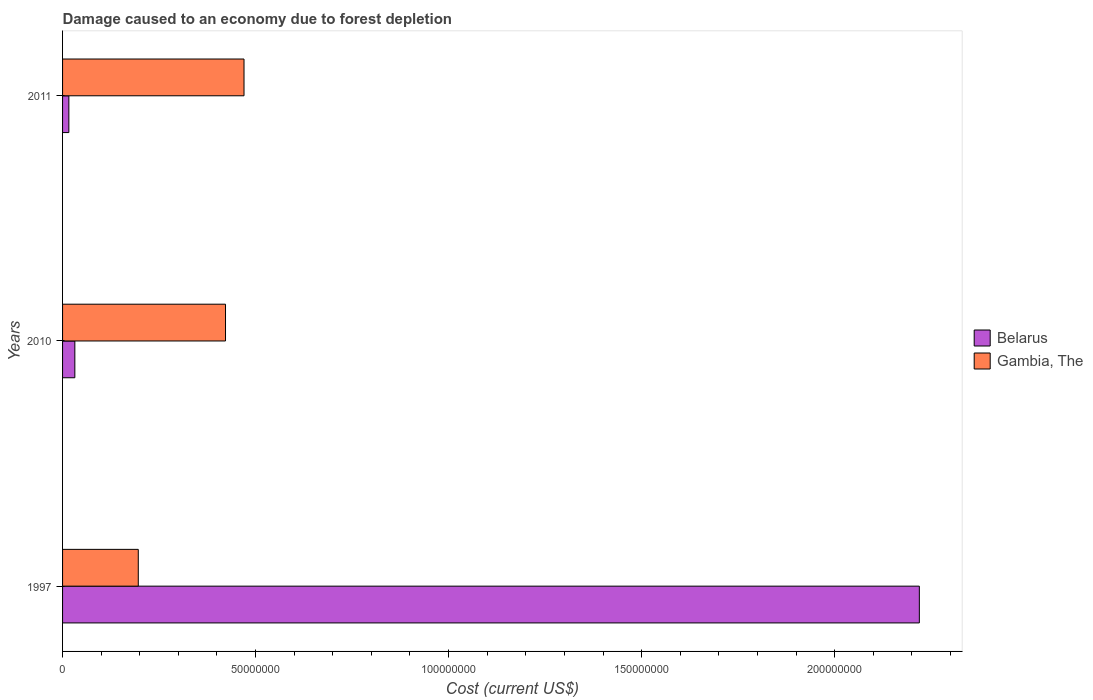How many different coloured bars are there?
Give a very brief answer. 2. How many bars are there on the 1st tick from the top?
Give a very brief answer. 2. How many bars are there on the 2nd tick from the bottom?
Ensure brevity in your answer.  2. What is the cost of damage caused due to forest depletion in Belarus in 2010?
Keep it short and to the point. 3.18e+06. Across all years, what is the maximum cost of damage caused due to forest depletion in Gambia, The?
Make the answer very short. 4.70e+07. Across all years, what is the minimum cost of damage caused due to forest depletion in Belarus?
Make the answer very short. 1.63e+06. In which year was the cost of damage caused due to forest depletion in Belarus maximum?
Give a very brief answer. 1997. What is the total cost of damage caused due to forest depletion in Gambia, The in the graph?
Your response must be concise. 1.09e+08. What is the difference between the cost of damage caused due to forest depletion in Belarus in 1997 and that in 2011?
Ensure brevity in your answer.  2.20e+08. What is the difference between the cost of damage caused due to forest depletion in Belarus in 2010 and the cost of damage caused due to forest depletion in Gambia, The in 2011?
Your answer should be very brief. -4.38e+07. What is the average cost of damage caused due to forest depletion in Gambia, The per year?
Give a very brief answer. 3.63e+07. In the year 2010, what is the difference between the cost of damage caused due to forest depletion in Gambia, The and cost of damage caused due to forest depletion in Belarus?
Your answer should be compact. 3.90e+07. What is the ratio of the cost of damage caused due to forest depletion in Gambia, The in 2010 to that in 2011?
Provide a succinct answer. 0.9. Is the cost of damage caused due to forest depletion in Gambia, The in 2010 less than that in 2011?
Your answer should be compact. Yes. What is the difference between the highest and the second highest cost of damage caused due to forest depletion in Gambia, The?
Make the answer very short. 4.79e+06. What is the difference between the highest and the lowest cost of damage caused due to forest depletion in Belarus?
Offer a terse response. 2.20e+08. In how many years, is the cost of damage caused due to forest depletion in Gambia, The greater than the average cost of damage caused due to forest depletion in Gambia, The taken over all years?
Provide a succinct answer. 2. What does the 2nd bar from the top in 2011 represents?
Keep it short and to the point. Belarus. What does the 1st bar from the bottom in 2010 represents?
Your answer should be compact. Belarus. How many years are there in the graph?
Your answer should be compact. 3. What is the difference between two consecutive major ticks on the X-axis?
Your response must be concise. 5.00e+07. Are the values on the major ticks of X-axis written in scientific E-notation?
Give a very brief answer. No. Does the graph contain grids?
Your answer should be compact. No. Where does the legend appear in the graph?
Keep it short and to the point. Center right. What is the title of the graph?
Offer a very short reply. Damage caused to an economy due to forest depletion. What is the label or title of the X-axis?
Give a very brief answer. Cost (current US$). What is the Cost (current US$) of Belarus in 1997?
Your response must be concise. 2.22e+08. What is the Cost (current US$) of Gambia, The in 1997?
Offer a very short reply. 1.96e+07. What is the Cost (current US$) of Belarus in 2010?
Your response must be concise. 3.18e+06. What is the Cost (current US$) in Gambia, The in 2010?
Your response must be concise. 4.22e+07. What is the Cost (current US$) in Belarus in 2011?
Give a very brief answer. 1.63e+06. What is the Cost (current US$) in Gambia, The in 2011?
Make the answer very short. 4.70e+07. Across all years, what is the maximum Cost (current US$) of Belarus?
Provide a succinct answer. 2.22e+08. Across all years, what is the maximum Cost (current US$) in Gambia, The?
Offer a terse response. 4.70e+07. Across all years, what is the minimum Cost (current US$) of Belarus?
Provide a short and direct response. 1.63e+06. Across all years, what is the minimum Cost (current US$) in Gambia, The?
Your response must be concise. 1.96e+07. What is the total Cost (current US$) of Belarus in the graph?
Offer a terse response. 2.27e+08. What is the total Cost (current US$) in Gambia, The in the graph?
Provide a succinct answer. 1.09e+08. What is the difference between the Cost (current US$) in Belarus in 1997 and that in 2010?
Keep it short and to the point. 2.19e+08. What is the difference between the Cost (current US$) of Gambia, The in 1997 and that in 2010?
Make the answer very short. -2.26e+07. What is the difference between the Cost (current US$) of Belarus in 1997 and that in 2011?
Offer a very short reply. 2.20e+08. What is the difference between the Cost (current US$) of Gambia, The in 1997 and that in 2011?
Your answer should be compact. -2.74e+07. What is the difference between the Cost (current US$) of Belarus in 2010 and that in 2011?
Your answer should be very brief. 1.55e+06. What is the difference between the Cost (current US$) of Gambia, The in 2010 and that in 2011?
Your answer should be very brief. -4.79e+06. What is the difference between the Cost (current US$) in Belarus in 1997 and the Cost (current US$) in Gambia, The in 2010?
Offer a very short reply. 1.80e+08. What is the difference between the Cost (current US$) in Belarus in 1997 and the Cost (current US$) in Gambia, The in 2011?
Keep it short and to the point. 1.75e+08. What is the difference between the Cost (current US$) in Belarus in 2010 and the Cost (current US$) in Gambia, The in 2011?
Offer a terse response. -4.38e+07. What is the average Cost (current US$) in Belarus per year?
Your answer should be very brief. 7.56e+07. What is the average Cost (current US$) in Gambia, The per year?
Give a very brief answer. 3.63e+07. In the year 1997, what is the difference between the Cost (current US$) of Belarus and Cost (current US$) of Gambia, The?
Offer a terse response. 2.02e+08. In the year 2010, what is the difference between the Cost (current US$) of Belarus and Cost (current US$) of Gambia, The?
Your answer should be very brief. -3.90e+07. In the year 2011, what is the difference between the Cost (current US$) of Belarus and Cost (current US$) of Gambia, The?
Give a very brief answer. -4.54e+07. What is the ratio of the Cost (current US$) of Belarus in 1997 to that in 2010?
Provide a short and direct response. 69.75. What is the ratio of the Cost (current US$) in Gambia, The in 1997 to that in 2010?
Provide a short and direct response. 0.46. What is the ratio of the Cost (current US$) in Belarus in 1997 to that in 2011?
Provide a succinct answer. 136. What is the ratio of the Cost (current US$) of Gambia, The in 1997 to that in 2011?
Offer a terse response. 0.42. What is the ratio of the Cost (current US$) of Belarus in 2010 to that in 2011?
Your response must be concise. 1.95. What is the ratio of the Cost (current US$) in Gambia, The in 2010 to that in 2011?
Offer a terse response. 0.9. What is the difference between the highest and the second highest Cost (current US$) in Belarus?
Ensure brevity in your answer.  2.19e+08. What is the difference between the highest and the second highest Cost (current US$) in Gambia, The?
Offer a terse response. 4.79e+06. What is the difference between the highest and the lowest Cost (current US$) in Belarus?
Offer a terse response. 2.20e+08. What is the difference between the highest and the lowest Cost (current US$) in Gambia, The?
Make the answer very short. 2.74e+07. 